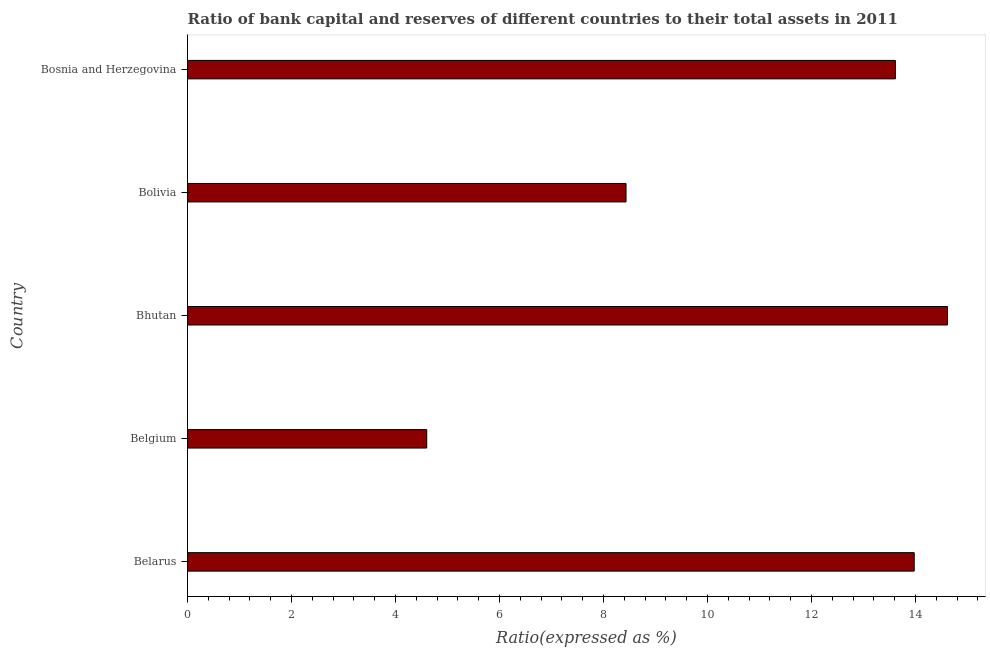Does the graph contain any zero values?
Your answer should be compact. No. What is the title of the graph?
Your response must be concise. Ratio of bank capital and reserves of different countries to their total assets in 2011. What is the label or title of the X-axis?
Make the answer very short. Ratio(expressed as %). What is the label or title of the Y-axis?
Keep it short and to the point. Country. What is the bank capital to assets ratio in Belarus?
Keep it short and to the point. 13.98. Across all countries, what is the maximum bank capital to assets ratio?
Ensure brevity in your answer.  14.62. Across all countries, what is the minimum bank capital to assets ratio?
Give a very brief answer. 4.6. In which country was the bank capital to assets ratio maximum?
Provide a short and direct response. Bhutan. In which country was the bank capital to assets ratio minimum?
Offer a very short reply. Belgium. What is the sum of the bank capital to assets ratio?
Make the answer very short. 55.24. What is the difference between the bank capital to assets ratio in Bolivia and Bosnia and Herzegovina?
Give a very brief answer. -5.18. What is the average bank capital to assets ratio per country?
Provide a short and direct response. 11.05. What is the median bank capital to assets ratio?
Your answer should be compact. 13.61. What is the ratio of the bank capital to assets ratio in Belarus to that in Bosnia and Herzegovina?
Your answer should be very brief. 1.03. Is the bank capital to assets ratio in Belgium less than that in Bolivia?
Keep it short and to the point. Yes. Is the difference between the bank capital to assets ratio in Belgium and Bosnia and Herzegovina greater than the difference between any two countries?
Keep it short and to the point. No. What is the difference between the highest and the second highest bank capital to assets ratio?
Make the answer very short. 0.64. What is the difference between the highest and the lowest bank capital to assets ratio?
Provide a succinct answer. 10.02. In how many countries, is the bank capital to assets ratio greater than the average bank capital to assets ratio taken over all countries?
Ensure brevity in your answer.  3. Are all the bars in the graph horizontal?
Offer a very short reply. Yes. What is the Ratio(expressed as %) of Belarus?
Ensure brevity in your answer.  13.98. What is the Ratio(expressed as %) in Belgium?
Offer a terse response. 4.6. What is the Ratio(expressed as %) of Bhutan?
Offer a very short reply. 14.62. What is the Ratio(expressed as %) of Bolivia?
Make the answer very short. 8.43. What is the Ratio(expressed as %) in Bosnia and Herzegovina?
Keep it short and to the point. 13.61. What is the difference between the Ratio(expressed as %) in Belarus and Belgium?
Your answer should be compact. 9.38. What is the difference between the Ratio(expressed as %) in Belarus and Bhutan?
Give a very brief answer. -0.64. What is the difference between the Ratio(expressed as %) in Belarus and Bolivia?
Provide a short and direct response. 5.54. What is the difference between the Ratio(expressed as %) in Belarus and Bosnia and Herzegovina?
Give a very brief answer. 0.36. What is the difference between the Ratio(expressed as %) in Belgium and Bhutan?
Offer a very short reply. -10.02. What is the difference between the Ratio(expressed as %) in Belgium and Bolivia?
Ensure brevity in your answer.  -3.83. What is the difference between the Ratio(expressed as %) in Belgium and Bosnia and Herzegovina?
Provide a succinct answer. -9.01. What is the difference between the Ratio(expressed as %) in Bhutan and Bolivia?
Give a very brief answer. 6.18. What is the difference between the Ratio(expressed as %) in Bhutan and Bosnia and Herzegovina?
Your response must be concise. 1. What is the difference between the Ratio(expressed as %) in Bolivia and Bosnia and Herzegovina?
Provide a short and direct response. -5.18. What is the ratio of the Ratio(expressed as %) in Belarus to that in Belgium?
Ensure brevity in your answer.  3.04. What is the ratio of the Ratio(expressed as %) in Belarus to that in Bhutan?
Offer a terse response. 0.96. What is the ratio of the Ratio(expressed as %) in Belarus to that in Bolivia?
Ensure brevity in your answer.  1.66. What is the ratio of the Ratio(expressed as %) in Belarus to that in Bosnia and Herzegovina?
Keep it short and to the point. 1.03. What is the ratio of the Ratio(expressed as %) in Belgium to that in Bhutan?
Your answer should be compact. 0.32. What is the ratio of the Ratio(expressed as %) in Belgium to that in Bolivia?
Ensure brevity in your answer.  0.55. What is the ratio of the Ratio(expressed as %) in Belgium to that in Bosnia and Herzegovina?
Ensure brevity in your answer.  0.34. What is the ratio of the Ratio(expressed as %) in Bhutan to that in Bolivia?
Your answer should be compact. 1.73. What is the ratio of the Ratio(expressed as %) in Bhutan to that in Bosnia and Herzegovina?
Ensure brevity in your answer.  1.07. What is the ratio of the Ratio(expressed as %) in Bolivia to that in Bosnia and Herzegovina?
Your answer should be very brief. 0.62. 